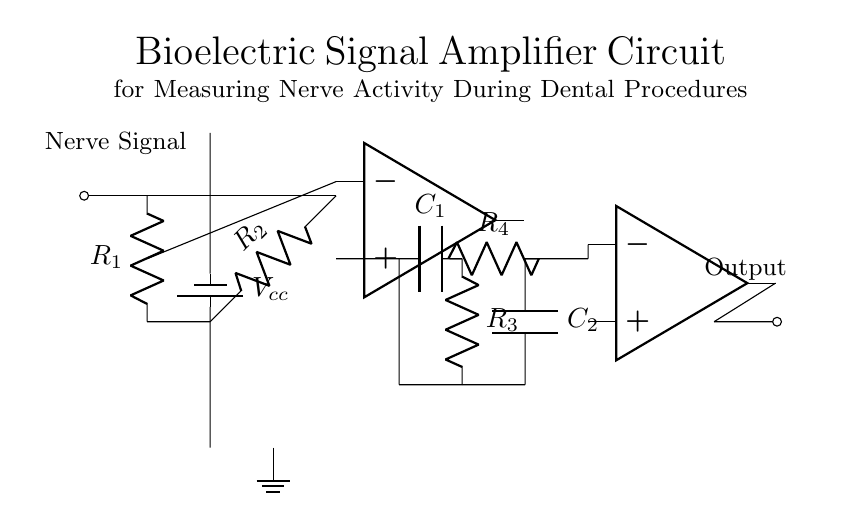What is the input signal in this circuit? The input signal is labeled "Nerve Signal", which indicates that this circuit is designed to measure nerve activity.
Answer: Nerve Signal What type of amplifier is used in this circuit? The circuit contains an operational amplifier, as indicated by the op amp symbol, which is commonly used for signal amplification.
Answer: Operational amplifier What is the purpose of the capacitor labeled C1? The capacitor C1 is part of a high-pass filter, which allows only signals above a certain frequency to pass, blocking lower frequency noise.
Answer: High-pass filter How many resistors are present in this circuit? There are four resistors present, labeled as R1, R2, R3, and R4, which play various roles in signal conditioning.
Answer: Four What is the role of the output buffer in this circuit? The output buffer, represented by the second operational amplifier, isolates the output from the filtering stages to prevent loading effects and ensure a stable output signal.
Answer: Isolates output What components form the low-pass filter section? The low-pass filter consists of resistor R4 and capacitor C2, which allows low-frequency signals to pass while attenuating higher frequency signals.
Answer: R4 and C2 What is the voltage supply labeled as Vcc? The voltage supply Vcc provides the necessary power for the operational amplifiers to function correctly within the circuit.
Answer: Supply voltage 